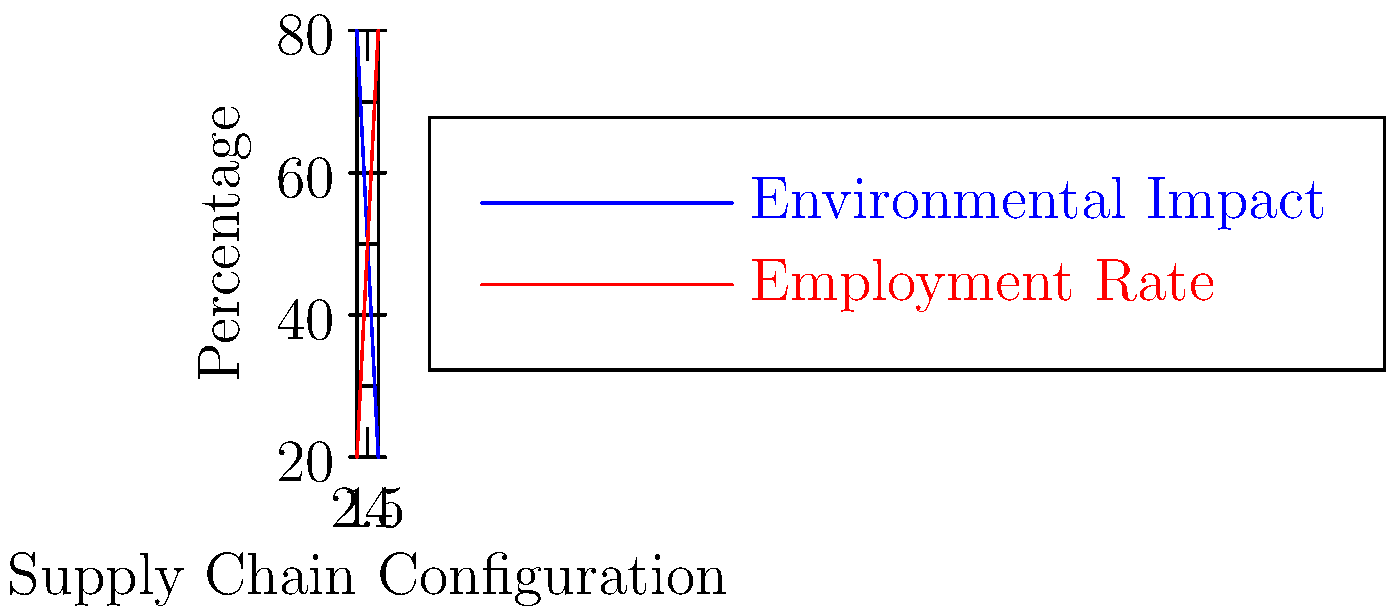The graph shows the relationship between different supply chain configurations and their impact on environmental sustainability and employment rates. Which supply chain configuration provides the best balance between minimizing environmental impact and maximizing employment rates? To determine the best balance between environmental impact and employment rates, we need to analyze the graph step-by-step:

1. The blue line represents the environmental impact, where lower values are better (less impact).
2. The red line represents the employment rate, where higher values are better (more jobs).
3. We need to find the point where these two lines are closest, indicating a balance between the two factors.

Analyzing each configuration:
1. Configuration 1: High environmental impact (80%), low employment (20%)
2. Configuration 2: Moderate environmental impact (60%), moderate employment (40%)
3. Configuration 3: Moderate environmental impact (40%), moderate employment (60%)
4. Configuration 4: Low environmental impact (20%), high employment (80%)

Configuration 3 provides the best balance because:
- The environmental impact is relatively low (40%)
- The employment rate is relatively high (60%)
- This is the point where the two lines are closest, indicating the smallest trade-off between the two factors

Therefore, Configuration 3 offers the optimal balance between minimizing environmental impact and maximizing employment rates.
Answer: Configuration 3 